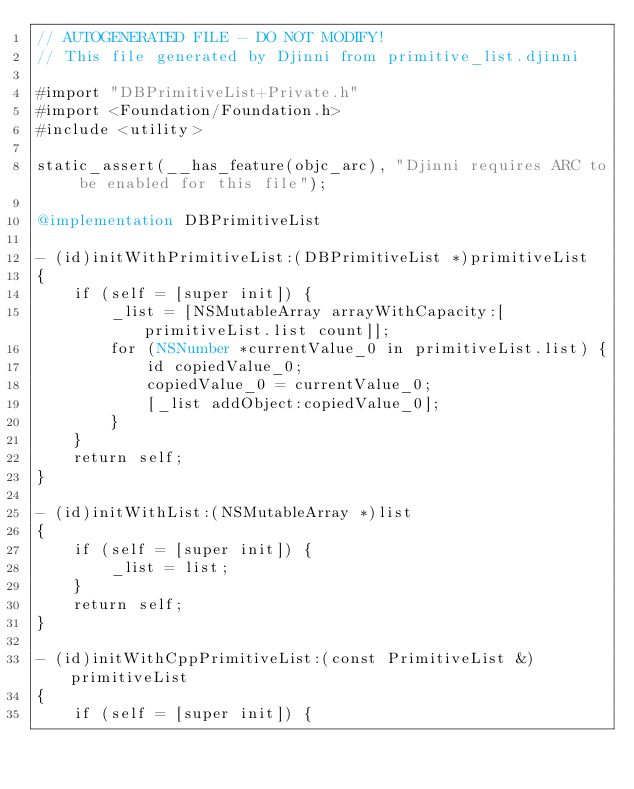Convert code to text. <code><loc_0><loc_0><loc_500><loc_500><_ObjectiveC_>// AUTOGENERATED FILE - DO NOT MODIFY!
// This file generated by Djinni from primitive_list.djinni

#import "DBPrimitiveList+Private.h"
#import <Foundation/Foundation.h>
#include <utility>

static_assert(__has_feature(objc_arc), "Djinni requires ARC to be enabled for this file");

@implementation DBPrimitiveList

- (id)initWithPrimitiveList:(DBPrimitiveList *)primitiveList
{
    if (self = [super init]) {
        _list = [NSMutableArray arrayWithCapacity:[primitiveList.list count]];
        for (NSNumber *currentValue_0 in primitiveList.list) {
            id copiedValue_0;
            copiedValue_0 = currentValue_0;
            [_list addObject:copiedValue_0];
        }
    }
    return self;
}

- (id)initWithList:(NSMutableArray *)list
{
    if (self = [super init]) {
        _list = list;
    }
    return self;
}

- (id)initWithCppPrimitiveList:(const PrimitiveList &)primitiveList
{
    if (self = [super init]) {</code> 